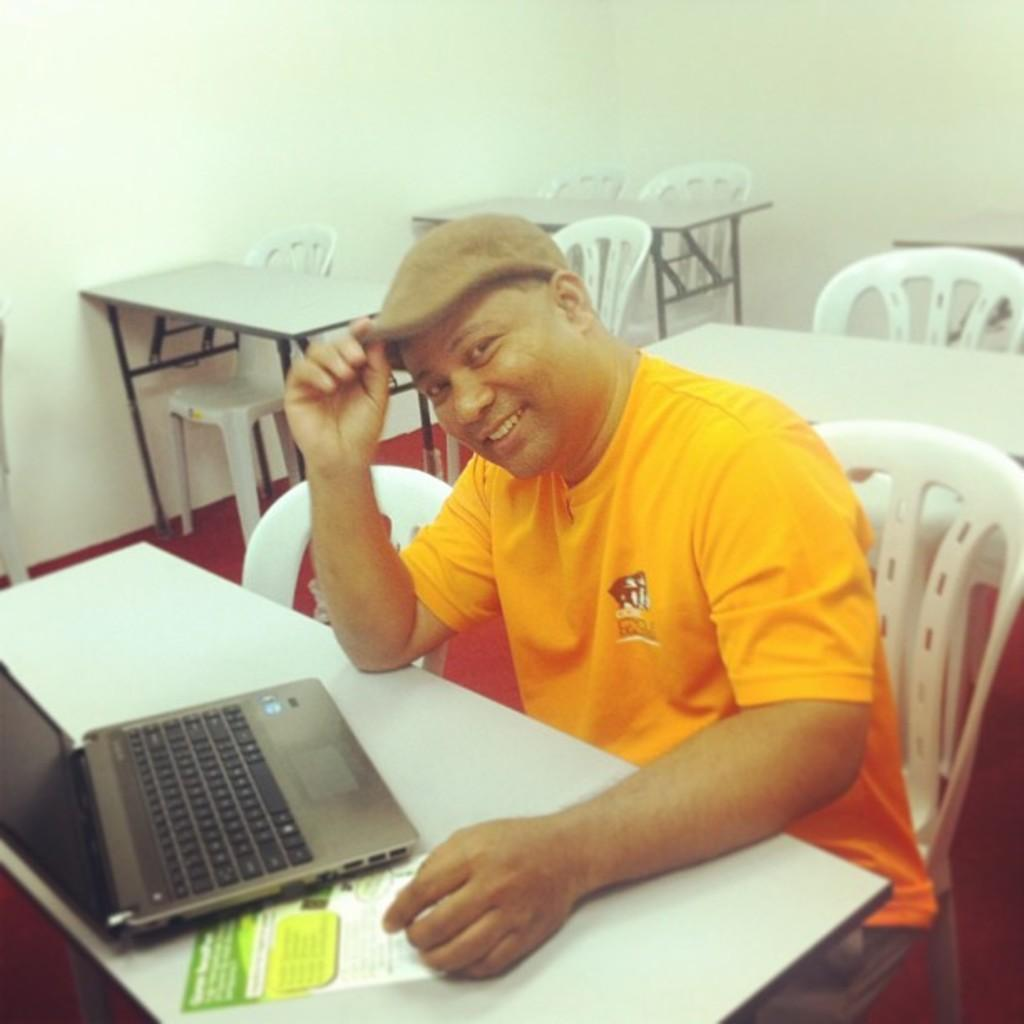What type of furniture is present in the image? There are chairs and a table in the image. What can be seen on the wall in the image? There is a wall in the image, but no specific details are provided about what is on the wall. What is the person in the image doing? The person is sitting on a chair and holding a cap. What objects are on the table in the image? There is a laptop and a poster on the table in the image. Is the person in the image standing in quicksand? There is no quicksand present in the image, and the person is sitting on a chair. How many feet can be seen in the image? The provided facts do not mention any feet, so it is impossible to determine how many can be seen in the image. 